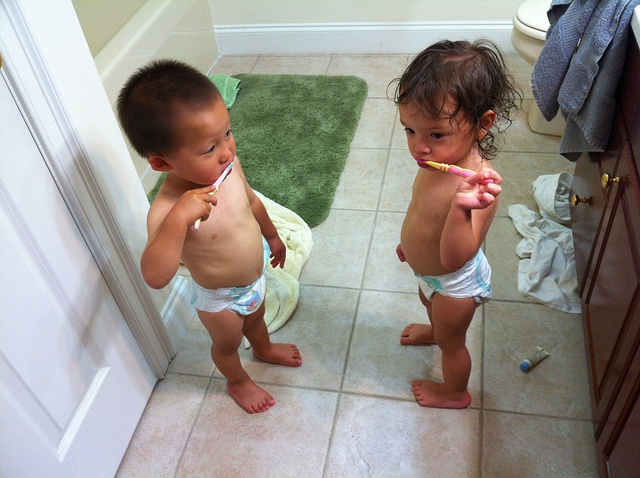Describe the objects in this image and their specific colors. I can see people in darkgray, brown, black, and maroon tones, people in darkgray, maroon, brown, and black tones, toilet in darkgray, ivory, and gray tones, toothbrush in darkgray, khaki, lightpink, salmon, and brown tones, and toothbrush in darkgray, white, brown, khaki, and turquoise tones in this image. 